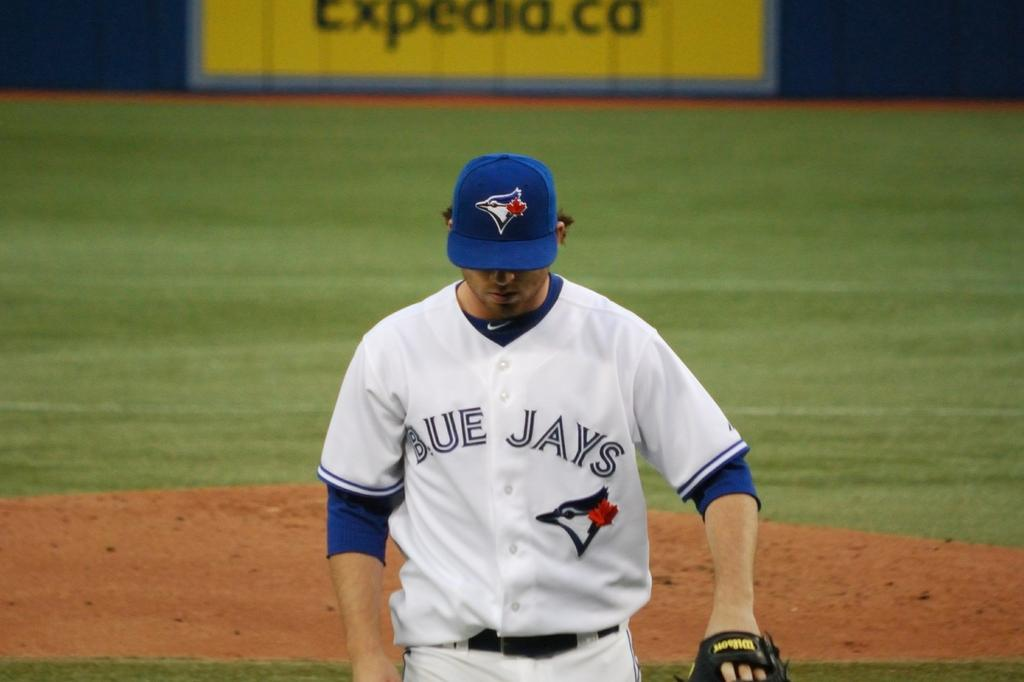<image>
Present a compact description of the photo's key features. a man who plays for the blue jays is wearing a blue hat 